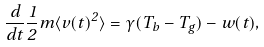Convert formula to latex. <formula><loc_0><loc_0><loc_500><loc_500>\frac { d } { d t } \frac { 1 } { 2 } m \langle v ( t ) ^ { 2 } \rangle = \gamma ( T _ { b } - T _ { g } ) - w ( t ) ,</formula> 